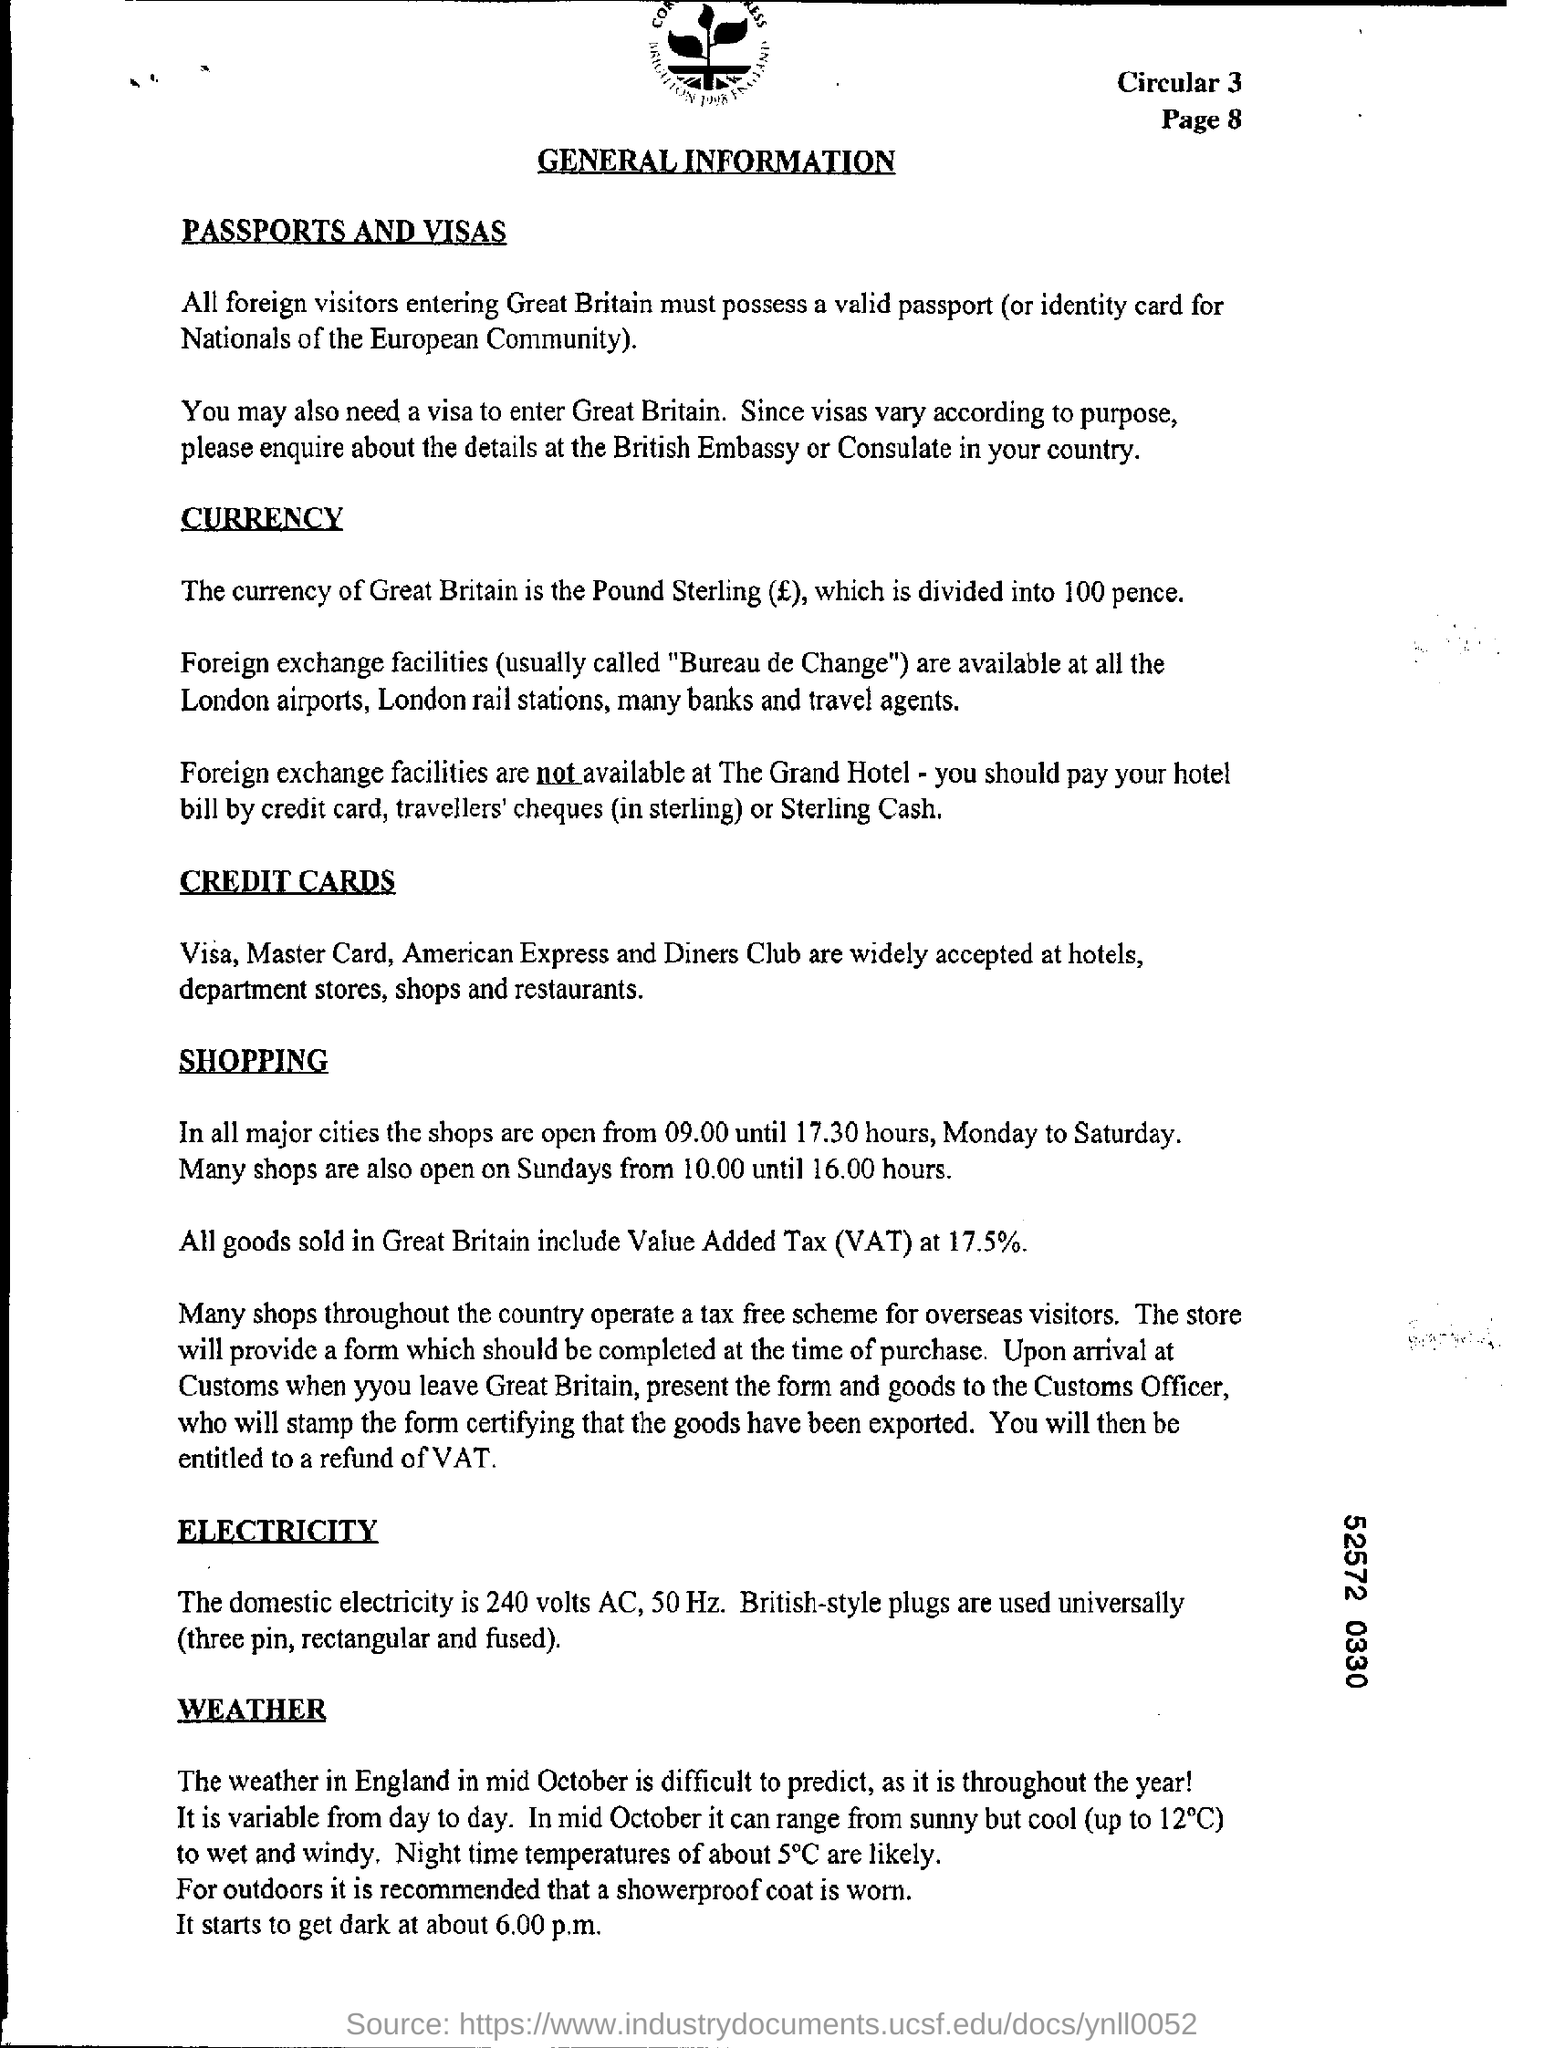What is the Currency of Great Britain?
Make the answer very short. Pound Sterling. 